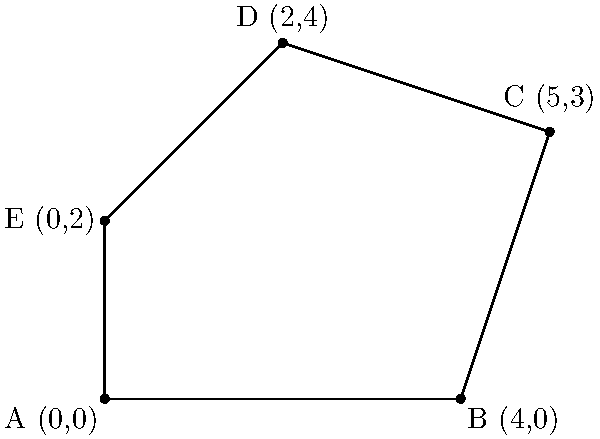In your latest novel, you've plotted key events on a coordinate system to visualize the story's structure. The coordinates (0,0), (4,0), (5,3), (2,4), and (0,2) represent crucial plot points. If you connect these points in order, forming a closed shape, what is the area of the resulting polygon? Round your answer to two decimal places. To find the area of this irregular polygon, we can use the Shoelace formula (also known as the surveyor's formula). Here's how:

1) First, let's list our coordinates in order:
   (0,0), (4,0), (5,3), (2,4), (0,2)

2) The Shoelace formula is:
   $$Area = \frac{1}{2}|(x_1y_2 + x_2y_3 + ... + x_ny_1) - (y_1x_2 + y_2x_3 + ... + y_nx_1)|$$

3) Let's apply the formula:
   $$\begin{align}
   Area &= \frac{1}{2}|(0\cdot0 + 4\cdot3 + 5\cdot4 + 2\cdot2 + 0\cdot0) \\
   &\quad - (0\cdot4 + 0\cdot5 + 3\cdot2 + 4\cdot0 + 2\cdot0)|
   \end{align}$$

4) Simplify:
   $$\begin{align}
   Area &= \frac{1}{2}|(0 + 12 + 20 + 4 + 0) - (0 + 0 + 6 + 0 + 0)| \\
   &= \frac{1}{2}|36 - 6| \\
   &= \frac{1}{2}|30| \\
   &= 15
   \end{align}$$

5) The area is 15 square units.
Answer: 15 square units 